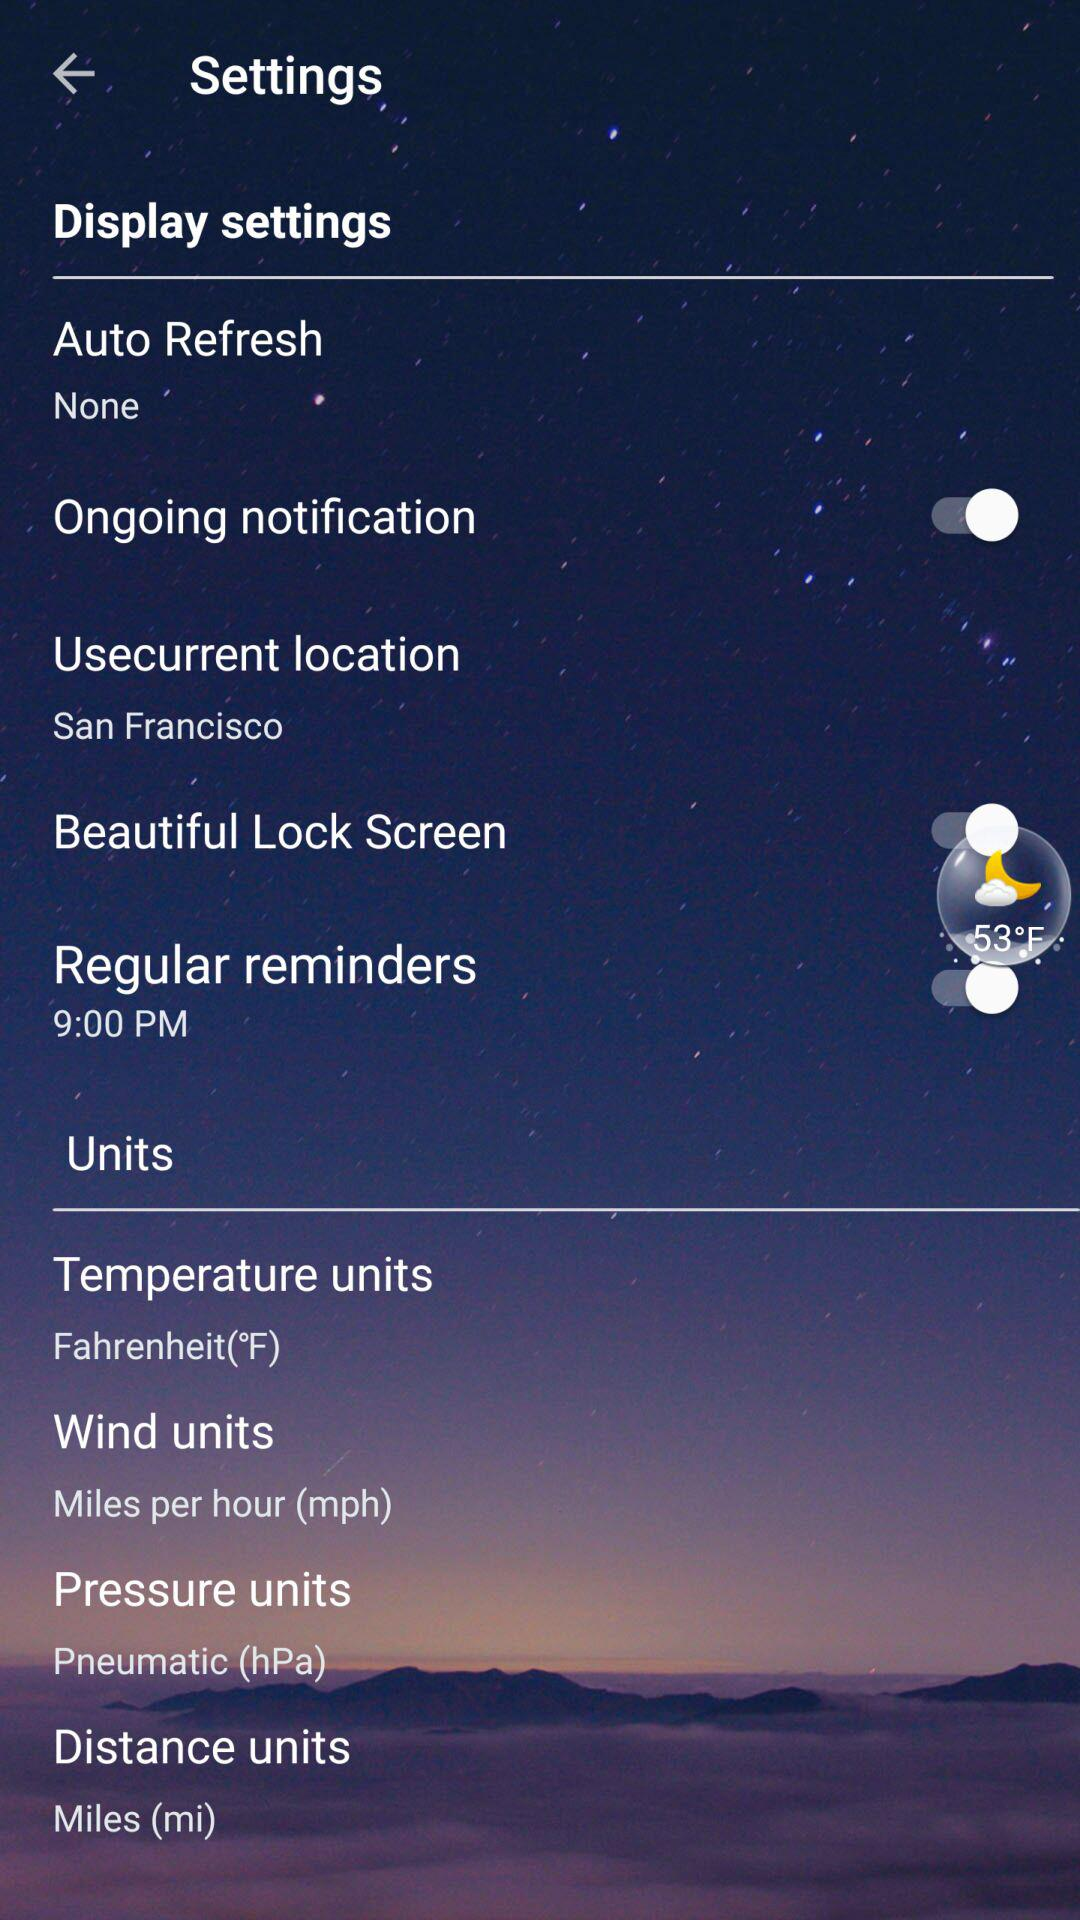What is the status of "Ongoing notification"? The status of "Ongoing notification" is "off". 